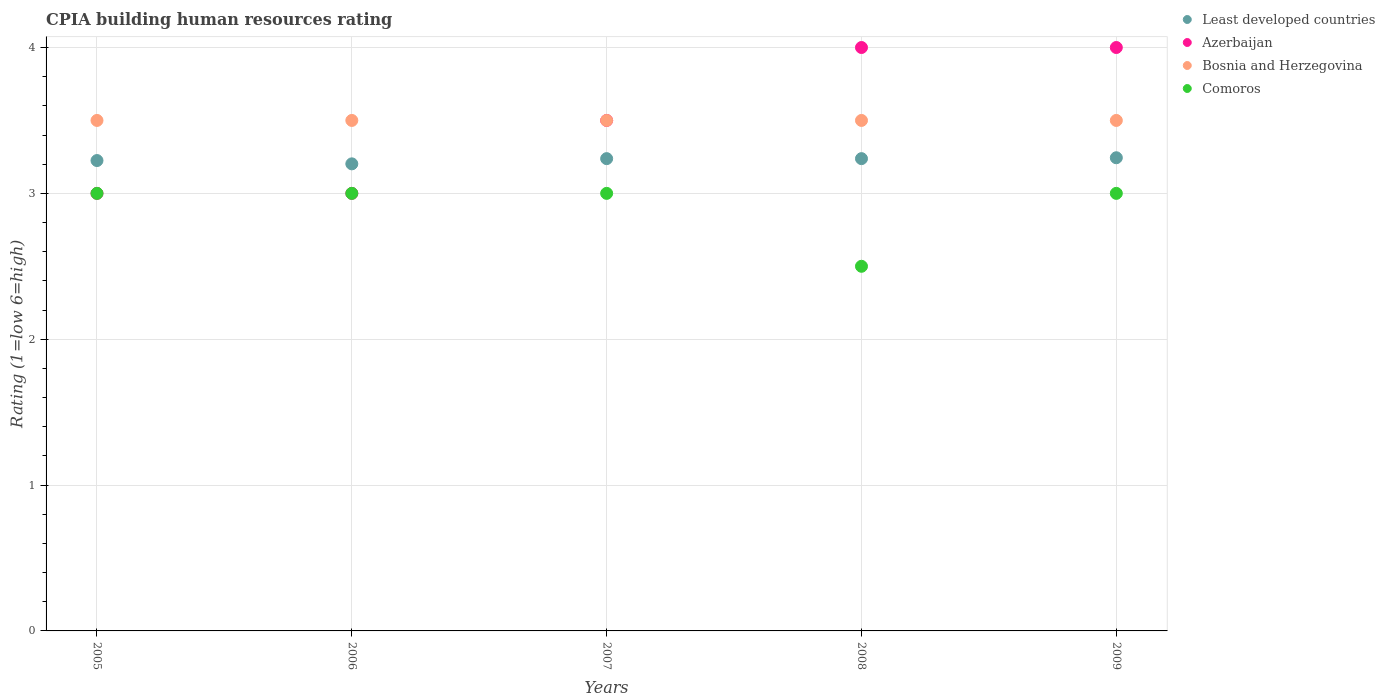How many different coloured dotlines are there?
Your answer should be compact. 4. Is the number of dotlines equal to the number of legend labels?
Your response must be concise. Yes. Across all years, what is the minimum CPIA rating in Least developed countries?
Your answer should be compact. 3.2. What is the total CPIA rating in Bosnia and Herzegovina in the graph?
Ensure brevity in your answer.  17.5. What is the difference between the CPIA rating in Azerbaijan in 2006 and that in 2008?
Your response must be concise. -1. What is the difference between the CPIA rating in Bosnia and Herzegovina in 2005 and the CPIA rating in Azerbaijan in 2009?
Provide a succinct answer. -0.5. What is the average CPIA rating in Least developed countries per year?
Your answer should be very brief. 3.23. In how many years, is the CPIA rating in Bosnia and Herzegovina greater than 2.4?
Give a very brief answer. 5. In how many years, is the CPIA rating in Bosnia and Herzegovina greater than the average CPIA rating in Bosnia and Herzegovina taken over all years?
Your answer should be compact. 0. Is the sum of the CPIA rating in Azerbaijan in 2005 and 2008 greater than the maximum CPIA rating in Comoros across all years?
Give a very brief answer. Yes. Is the CPIA rating in Bosnia and Herzegovina strictly less than the CPIA rating in Comoros over the years?
Your answer should be very brief. No. How many dotlines are there?
Make the answer very short. 4. Does the graph contain any zero values?
Keep it short and to the point. No. Does the graph contain grids?
Make the answer very short. Yes. How many legend labels are there?
Offer a terse response. 4. How are the legend labels stacked?
Provide a succinct answer. Vertical. What is the title of the graph?
Your answer should be very brief. CPIA building human resources rating. Does "Lower middle income" appear as one of the legend labels in the graph?
Make the answer very short. No. What is the label or title of the X-axis?
Your answer should be very brief. Years. What is the Rating (1=low 6=high) of Least developed countries in 2005?
Give a very brief answer. 3.23. What is the Rating (1=low 6=high) of Comoros in 2005?
Your response must be concise. 3. What is the Rating (1=low 6=high) of Least developed countries in 2006?
Make the answer very short. 3.2. What is the Rating (1=low 6=high) of Azerbaijan in 2006?
Your answer should be compact. 3. What is the Rating (1=low 6=high) in Bosnia and Herzegovina in 2006?
Offer a very short reply. 3.5. What is the Rating (1=low 6=high) of Least developed countries in 2007?
Keep it short and to the point. 3.24. What is the Rating (1=low 6=high) in Bosnia and Herzegovina in 2007?
Keep it short and to the point. 3.5. What is the Rating (1=low 6=high) of Comoros in 2007?
Make the answer very short. 3. What is the Rating (1=low 6=high) of Least developed countries in 2008?
Provide a succinct answer. 3.24. What is the Rating (1=low 6=high) of Azerbaijan in 2008?
Ensure brevity in your answer.  4. What is the Rating (1=low 6=high) of Bosnia and Herzegovina in 2008?
Offer a very short reply. 3.5. What is the Rating (1=low 6=high) of Comoros in 2008?
Provide a short and direct response. 2.5. What is the Rating (1=low 6=high) in Least developed countries in 2009?
Offer a very short reply. 3.24. What is the Rating (1=low 6=high) of Azerbaijan in 2009?
Give a very brief answer. 4. What is the Rating (1=low 6=high) in Bosnia and Herzegovina in 2009?
Make the answer very short. 3.5. Across all years, what is the maximum Rating (1=low 6=high) of Least developed countries?
Your answer should be compact. 3.24. Across all years, what is the maximum Rating (1=low 6=high) in Azerbaijan?
Ensure brevity in your answer.  4. Across all years, what is the maximum Rating (1=low 6=high) of Bosnia and Herzegovina?
Your answer should be very brief. 3.5. Across all years, what is the maximum Rating (1=low 6=high) in Comoros?
Offer a terse response. 3. Across all years, what is the minimum Rating (1=low 6=high) of Least developed countries?
Your response must be concise. 3.2. Across all years, what is the minimum Rating (1=low 6=high) of Azerbaijan?
Provide a succinct answer. 3. Across all years, what is the minimum Rating (1=low 6=high) in Comoros?
Provide a short and direct response. 2.5. What is the total Rating (1=low 6=high) of Least developed countries in the graph?
Ensure brevity in your answer.  16.15. What is the difference between the Rating (1=low 6=high) in Least developed countries in 2005 and that in 2006?
Offer a very short reply. 0.02. What is the difference between the Rating (1=low 6=high) of Bosnia and Herzegovina in 2005 and that in 2006?
Give a very brief answer. 0. What is the difference between the Rating (1=low 6=high) in Comoros in 2005 and that in 2006?
Provide a succinct answer. 0. What is the difference between the Rating (1=low 6=high) in Least developed countries in 2005 and that in 2007?
Make the answer very short. -0.01. What is the difference between the Rating (1=low 6=high) of Azerbaijan in 2005 and that in 2007?
Your response must be concise. -0.5. What is the difference between the Rating (1=low 6=high) in Bosnia and Herzegovina in 2005 and that in 2007?
Give a very brief answer. 0. What is the difference between the Rating (1=low 6=high) of Least developed countries in 2005 and that in 2008?
Provide a short and direct response. -0.01. What is the difference between the Rating (1=low 6=high) in Azerbaijan in 2005 and that in 2008?
Offer a very short reply. -1. What is the difference between the Rating (1=low 6=high) of Least developed countries in 2005 and that in 2009?
Your answer should be very brief. -0.02. What is the difference between the Rating (1=low 6=high) of Azerbaijan in 2005 and that in 2009?
Your answer should be very brief. -1. What is the difference between the Rating (1=low 6=high) in Least developed countries in 2006 and that in 2007?
Provide a short and direct response. -0.04. What is the difference between the Rating (1=low 6=high) in Least developed countries in 2006 and that in 2008?
Give a very brief answer. -0.04. What is the difference between the Rating (1=low 6=high) in Bosnia and Herzegovina in 2006 and that in 2008?
Your answer should be very brief. 0. What is the difference between the Rating (1=low 6=high) of Comoros in 2006 and that in 2008?
Your answer should be compact. 0.5. What is the difference between the Rating (1=low 6=high) in Least developed countries in 2006 and that in 2009?
Give a very brief answer. -0.04. What is the difference between the Rating (1=low 6=high) in Azerbaijan in 2006 and that in 2009?
Give a very brief answer. -1. What is the difference between the Rating (1=low 6=high) in Bosnia and Herzegovina in 2006 and that in 2009?
Your response must be concise. 0. What is the difference between the Rating (1=low 6=high) of Azerbaijan in 2007 and that in 2008?
Keep it short and to the point. -0.5. What is the difference between the Rating (1=low 6=high) in Bosnia and Herzegovina in 2007 and that in 2008?
Give a very brief answer. 0. What is the difference between the Rating (1=low 6=high) of Comoros in 2007 and that in 2008?
Your answer should be compact. 0.5. What is the difference between the Rating (1=low 6=high) of Least developed countries in 2007 and that in 2009?
Provide a succinct answer. -0.01. What is the difference between the Rating (1=low 6=high) in Azerbaijan in 2007 and that in 2009?
Offer a very short reply. -0.5. What is the difference between the Rating (1=low 6=high) of Least developed countries in 2008 and that in 2009?
Make the answer very short. -0.01. What is the difference between the Rating (1=low 6=high) in Azerbaijan in 2008 and that in 2009?
Your answer should be compact. 0. What is the difference between the Rating (1=low 6=high) of Bosnia and Herzegovina in 2008 and that in 2009?
Provide a short and direct response. 0. What is the difference between the Rating (1=low 6=high) in Least developed countries in 2005 and the Rating (1=low 6=high) in Azerbaijan in 2006?
Your answer should be very brief. 0.23. What is the difference between the Rating (1=low 6=high) in Least developed countries in 2005 and the Rating (1=low 6=high) in Bosnia and Herzegovina in 2006?
Your answer should be very brief. -0.28. What is the difference between the Rating (1=low 6=high) in Least developed countries in 2005 and the Rating (1=low 6=high) in Comoros in 2006?
Offer a very short reply. 0.23. What is the difference between the Rating (1=low 6=high) of Least developed countries in 2005 and the Rating (1=low 6=high) of Azerbaijan in 2007?
Ensure brevity in your answer.  -0.28. What is the difference between the Rating (1=low 6=high) of Least developed countries in 2005 and the Rating (1=low 6=high) of Bosnia and Herzegovina in 2007?
Ensure brevity in your answer.  -0.28. What is the difference between the Rating (1=low 6=high) in Least developed countries in 2005 and the Rating (1=low 6=high) in Comoros in 2007?
Ensure brevity in your answer.  0.23. What is the difference between the Rating (1=low 6=high) of Azerbaijan in 2005 and the Rating (1=low 6=high) of Comoros in 2007?
Provide a short and direct response. 0. What is the difference between the Rating (1=low 6=high) of Least developed countries in 2005 and the Rating (1=low 6=high) of Azerbaijan in 2008?
Ensure brevity in your answer.  -0.78. What is the difference between the Rating (1=low 6=high) of Least developed countries in 2005 and the Rating (1=low 6=high) of Bosnia and Herzegovina in 2008?
Your answer should be very brief. -0.28. What is the difference between the Rating (1=low 6=high) in Least developed countries in 2005 and the Rating (1=low 6=high) in Comoros in 2008?
Offer a terse response. 0.72. What is the difference between the Rating (1=low 6=high) in Azerbaijan in 2005 and the Rating (1=low 6=high) in Comoros in 2008?
Give a very brief answer. 0.5. What is the difference between the Rating (1=low 6=high) of Bosnia and Herzegovina in 2005 and the Rating (1=low 6=high) of Comoros in 2008?
Ensure brevity in your answer.  1. What is the difference between the Rating (1=low 6=high) of Least developed countries in 2005 and the Rating (1=low 6=high) of Azerbaijan in 2009?
Offer a very short reply. -0.78. What is the difference between the Rating (1=low 6=high) in Least developed countries in 2005 and the Rating (1=low 6=high) in Bosnia and Herzegovina in 2009?
Your response must be concise. -0.28. What is the difference between the Rating (1=low 6=high) of Least developed countries in 2005 and the Rating (1=low 6=high) of Comoros in 2009?
Your answer should be compact. 0.23. What is the difference between the Rating (1=low 6=high) in Azerbaijan in 2005 and the Rating (1=low 6=high) in Comoros in 2009?
Ensure brevity in your answer.  0. What is the difference between the Rating (1=low 6=high) of Bosnia and Herzegovina in 2005 and the Rating (1=low 6=high) of Comoros in 2009?
Offer a very short reply. 0.5. What is the difference between the Rating (1=low 6=high) of Least developed countries in 2006 and the Rating (1=low 6=high) of Azerbaijan in 2007?
Offer a terse response. -0.3. What is the difference between the Rating (1=low 6=high) in Least developed countries in 2006 and the Rating (1=low 6=high) in Bosnia and Herzegovina in 2007?
Make the answer very short. -0.3. What is the difference between the Rating (1=low 6=high) in Least developed countries in 2006 and the Rating (1=low 6=high) in Comoros in 2007?
Give a very brief answer. 0.2. What is the difference between the Rating (1=low 6=high) in Azerbaijan in 2006 and the Rating (1=low 6=high) in Bosnia and Herzegovina in 2007?
Offer a terse response. -0.5. What is the difference between the Rating (1=low 6=high) of Azerbaijan in 2006 and the Rating (1=low 6=high) of Comoros in 2007?
Provide a short and direct response. 0. What is the difference between the Rating (1=low 6=high) in Bosnia and Herzegovina in 2006 and the Rating (1=low 6=high) in Comoros in 2007?
Provide a succinct answer. 0.5. What is the difference between the Rating (1=low 6=high) of Least developed countries in 2006 and the Rating (1=low 6=high) of Azerbaijan in 2008?
Make the answer very short. -0.8. What is the difference between the Rating (1=low 6=high) of Least developed countries in 2006 and the Rating (1=low 6=high) of Bosnia and Herzegovina in 2008?
Offer a terse response. -0.3. What is the difference between the Rating (1=low 6=high) in Least developed countries in 2006 and the Rating (1=low 6=high) in Comoros in 2008?
Offer a very short reply. 0.7. What is the difference between the Rating (1=low 6=high) in Least developed countries in 2006 and the Rating (1=low 6=high) in Azerbaijan in 2009?
Make the answer very short. -0.8. What is the difference between the Rating (1=low 6=high) in Least developed countries in 2006 and the Rating (1=low 6=high) in Bosnia and Herzegovina in 2009?
Ensure brevity in your answer.  -0.3. What is the difference between the Rating (1=low 6=high) in Least developed countries in 2006 and the Rating (1=low 6=high) in Comoros in 2009?
Your answer should be very brief. 0.2. What is the difference between the Rating (1=low 6=high) in Azerbaijan in 2006 and the Rating (1=low 6=high) in Bosnia and Herzegovina in 2009?
Give a very brief answer. -0.5. What is the difference between the Rating (1=low 6=high) in Bosnia and Herzegovina in 2006 and the Rating (1=low 6=high) in Comoros in 2009?
Offer a terse response. 0.5. What is the difference between the Rating (1=low 6=high) of Least developed countries in 2007 and the Rating (1=low 6=high) of Azerbaijan in 2008?
Your response must be concise. -0.76. What is the difference between the Rating (1=low 6=high) of Least developed countries in 2007 and the Rating (1=low 6=high) of Bosnia and Herzegovina in 2008?
Keep it short and to the point. -0.26. What is the difference between the Rating (1=low 6=high) in Least developed countries in 2007 and the Rating (1=low 6=high) in Comoros in 2008?
Ensure brevity in your answer.  0.74. What is the difference between the Rating (1=low 6=high) in Azerbaijan in 2007 and the Rating (1=low 6=high) in Comoros in 2008?
Your answer should be very brief. 1. What is the difference between the Rating (1=low 6=high) in Bosnia and Herzegovina in 2007 and the Rating (1=low 6=high) in Comoros in 2008?
Your answer should be compact. 1. What is the difference between the Rating (1=low 6=high) in Least developed countries in 2007 and the Rating (1=low 6=high) in Azerbaijan in 2009?
Provide a succinct answer. -0.76. What is the difference between the Rating (1=low 6=high) of Least developed countries in 2007 and the Rating (1=low 6=high) of Bosnia and Herzegovina in 2009?
Make the answer very short. -0.26. What is the difference between the Rating (1=low 6=high) in Least developed countries in 2007 and the Rating (1=low 6=high) in Comoros in 2009?
Provide a succinct answer. 0.24. What is the difference between the Rating (1=low 6=high) of Azerbaijan in 2007 and the Rating (1=low 6=high) of Comoros in 2009?
Give a very brief answer. 0.5. What is the difference between the Rating (1=low 6=high) of Bosnia and Herzegovina in 2007 and the Rating (1=low 6=high) of Comoros in 2009?
Your answer should be compact. 0.5. What is the difference between the Rating (1=low 6=high) in Least developed countries in 2008 and the Rating (1=low 6=high) in Azerbaijan in 2009?
Make the answer very short. -0.76. What is the difference between the Rating (1=low 6=high) of Least developed countries in 2008 and the Rating (1=low 6=high) of Bosnia and Herzegovina in 2009?
Give a very brief answer. -0.26. What is the difference between the Rating (1=low 6=high) in Least developed countries in 2008 and the Rating (1=low 6=high) in Comoros in 2009?
Give a very brief answer. 0.24. What is the difference between the Rating (1=low 6=high) of Azerbaijan in 2008 and the Rating (1=low 6=high) of Comoros in 2009?
Provide a short and direct response. 1. What is the difference between the Rating (1=low 6=high) in Bosnia and Herzegovina in 2008 and the Rating (1=low 6=high) in Comoros in 2009?
Keep it short and to the point. 0.5. What is the average Rating (1=low 6=high) of Least developed countries per year?
Provide a short and direct response. 3.23. In the year 2005, what is the difference between the Rating (1=low 6=high) in Least developed countries and Rating (1=low 6=high) in Azerbaijan?
Ensure brevity in your answer.  0.23. In the year 2005, what is the difference between the Rating (1=low 6=high) of Least developed countries and Rating (1=low 6=high) of Bosnia and Herzegovina?
Offer a terse response. -0.28. In the year 2005, what is the difference between the Rating (1=low 6=high) in Least developed countries and Rating (1=low 6=high) in Comoros?
Offer a very short reply. 0.23. In the year 2005, what is the difference between the Rating (1=low 6=high) in Azerbaijan and Rating (1=low 6=high) in Comoros?
Ensure brevity in your answer.  0. In the year 2006, what is the difference between the Rating (1=low 6=high) of Least developed countries and Rating (1=low 6=high) of Azerbaijan?
Keep it short and to the point. 0.2. In the year 2006, what is the difference between the Rating (1=low 6=high) of Least developed countries and Rating (1=low 6=high) of Bosnia and Herzegovina?
Your answer should be very brief. -0.3. In the year 2006, what is the difference between the Rating (1=low 6=high) in Least developed countries and Rating (1=low 6=high) in Comoros?
Your answer should be very brief. 0.2. In the year 2006, what is the difference between the Rating (1=low 6=high) in Azerbaijan and Rating (1=low 6=high) in Comoros?
Give a very brief answer. 0. In the year 2007, what is the difference between the Rating (1=low 6=high) of Least developed countries and Rating (1=low 6=high) of Azerbaijan?
Provide a short and direct response. -0.26. In the year 2007, what is the difference between the Rating (1=low 6=high) in Least developed countries and Rating (1=low 6=high) in Bosnia and Herzegovina?
Provide a succinct answer. -0.26. In the year 2007, what is the difference between the Rating (1=low 6=high) in Least developed countries and Rating (1=low 6=high) in Comoros?
Your answer should be very brief. 0.24. In the year 2007, what is the difference between the Rating (1=low 6=high) in Azerbaijan and Rating (1=low 6=high) in Comoros?
Offer a very short reply. 0.5. In the year 2008, what is the difference between the Rating (1=low 6=high) in Least developed countries and Rating (1=low 6=high) in Azerbaijan?
Provide a short and direct response. -0.76. In the year 2008, what is the difference between the Rating (1=low 6=high) of Least developed countries and Rating (1=low 6=high) of Bosnia and Herzegovina?
Keep it short and to the point. -0.26. In the year 2008, what is the difference between the Rating (1=low 6=high) of Least developed countries and Rating (1=low 6=high) of Comoros?
Provide a short and direct response. 0.74. In the year 2008, what is the difference between the Rating (1=low 6=high) in Azerbaijan and Rating (1=low 6=high) in Comoros?
Keep it short and to the point. 1.5. In the year 2009, what is the difference between the Rating (1=low 6=high) in Least developed countries and Rating (1=low 6=high) in Azerbaijan?
Provide a succinct answer. -0.76. In the year 2009, what is the difference between the Rating (1=low 6=high) of Least developed countries and Rating (1=low 6=high) of Bosnia and Herzegovina?
Make the answer very short. -0.26. In the year 2009, what is the difference between the Rating (1=low 6=high) in Least developed countries and Rating (1=low 6=high) in Comoros?
Offer a terse response. 0.24. In the year 2009, what is the difference between the Rating (1=low 6=high) of Bosnia and Herzegovina and Rating (1=low 6=high) of Comoros?
Provide a short and direct response. 0.5. What is the ratio of the Rating (1=low 6=high) of Least developed countries in 2005 to that in 2006?
Provide a succinct answer. 1.01. What is the ratio of the Rating (1=low 6=high) in Azerbaijan in 2005 to that in 2006?
Provide a succinct answer. 1. What is the ratio of the Rating (1=low 6=high) in Comoros in 2005 to that in 2006?
Your response must be concise. 1. What is the ratio of the Rating (1=low 6=high) in Azerbaijan in 2005 to that in 2007?
Provide a short and direct response. 0.86. What is the ratio of the Rating (1=low 6=high) in Comoros in 2005 to that in 2007?
Offer a terse response. 1. What is the ratio of the Rating (1=low 6=high) of Least developed countries in 2005 to that in 2008?
Provide a short and direct response. 1. What is the ratio of the Rating (1=low 6=high) in Azerbaijan in 2005 to that in 2008?
Give a very brief answer. 0.75. What is the ratio of the Rating (1=low 6=high) of Least developed countries in 2005 to that in 2009?
Your answer should be very brief. 0.99. What is the ratio of the Rating (1=low 6=high) in Azerbaijan in 2005 to that in 2009?
Keep it short and to the point. 0.75. What is the ratio of the Rating (1=low 6=high) of Bosnia and Herzegovina in 2005 to that in 2009?
Your response must be concise. 1. What is the ratio of the Rating (1=low 6=high) of Azerbaijan in 2006 to that in 2007?
Offer a terse response. 0.86. What is the ratio of the Rating (1=low 6=high) in Comoros in 2006 to that in 2007?
Provide a succinct answer. 1. What is the ratio of the Rating (1=low 6=high) in Least developed countries in 2006 to that in 2008?
Offer a very short reply. 0.99. What is the ratio of the Rating (1=low 6=high) in Bosnia and Herzegovina in 2006 to that in 2008?
Ensure brevity in your answer.  1. What is the ratio of the Rating (1=low 6=high) in Least developed countries in 2006 to that in 2009?
Your response must be concise. 0.99. What is the ratio of the Rating (1=low 6=high) in Bosnia and Herzegovina in 2007 to that in 2008?
Your answer should be very brief. 1. What is the ratio of the Rating (1=low 6=high) of Comoros in 2007 to that in 2008?
Your response must be concise. 1.2. What is the ratio of the Rating (1=low 6=high) of Azerbaijan in 2007 to that in 2009?
Offer a terse response. 0.88. What is the ratio of the Rating (1=low 6=high) in Bosnia and Herzegovina in 2007 to that in 2009?
Ensure brevity in your answer.  1. What is the ratio of the Rating (1=low 6=high) of Least developed countries in 2008 to that in 2009?
Your response must be concise. 1. What is the ratio of the Rating (1=low 6=high) in Azerbaijan in 2008 to that in 2009?
Your answer should be very brief. 1. What is the difference between the highest and the second highest Rating (1=low 6=high) of Least developed countries?
Give a very brief answer. 0.01. What is the difference between the highest and the second highest Rating (1=low 6=high) of Azerbaijan?
Ensure brevity in your answer.  0. What is the difference between the highest and the second highest Rating (1=low 6=high) of Comoros?
Give a very brief answer. 0. What is the difference between the highest and the lowest Rating (1=low 6=high) of Least developed countries?
Make the answer very short. 0.04. What is the difference between the highest and the lowest Rating (1=low 6=high) in Azerbaijan?
Offer a very short reply. 1. What is the difference between the highest and the lowest Rating (1=low 6=high) of Bosnia and Herzegovina?
Provide a short and direct response. 0. What is the difference between the highest and the lowest Rating (1=low 6=high) in Comoros?
Offer a very short reply. 0.5. 